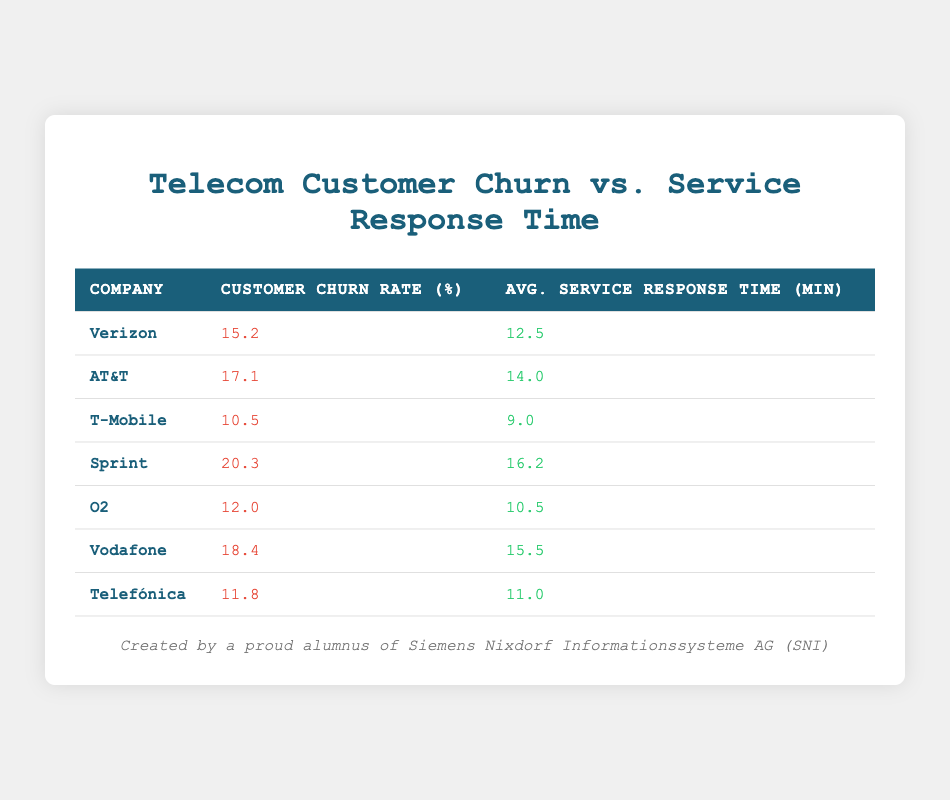What is the customer churn rate for Sprint? Sprint's customer churn rate is specifically listed in the table as 20.3%.
Answer: 20.3% Which company has the highest average service response time? The table shows that Sprint has the highest average service response time at 16.2 minutes.
Answer: Sprint What is the average customer churn rate for all the companies listed? To calculate the average, sum the customer churn rates: (15.2 + 17.1 + 10.5 + 20.3 + 12.0 + 18.4 + 11.8) = 105.3. There are 7 companies, so the average is 105.3 / 7 ≈ 15.04.
Answer: 15.04 Is the average service response time for T-Mobile less than 10 minutes? According to the table, T-Mobile's average service response time is 9.0 minutes, which is less than 10 minutes, making the statement true.
Answer: Yes Which company has the lowest customer churn rate, and how does it compare to the highest churn rate? The table indicates T-Mobile has the lowest churn rate at 10.5%. Sprint has the highest churn rate at 20.3%. The difference between them is 20.3 - 10.5 = 9.8 percentage points.
Answer: T-Mobile, 9.8 percentage points difference What is the total customer churn rate for the three companies with the lowest churn rates? The three companies with the lowest churn rates are T-Mobile (10.5%), Telefónica (11.8%), and O2 (12.0%). The total churn rate is (10.5 + 11.8 + 12.0) = 34.3%.
Answer: 34.3% Does Vodafone have a service response time greater than 15 minutes? Checking the table shows that Vodafone's response time is 15.5 minutes, which is indeed greater than 15 minutes, making the statement true.
Answer: Yes What is the median customer churn rate across the listed companies? To find the median, we first arrange the churn rates in ascending order: 10.5, 11.8, 12.0, 15.2, 17.1, 18.4, 20.3. With 7 values, the median is the 4th value, which is 15.2%.
Answer: 15.2% How does the average service response time for Verizon compare with that of O2? Verizon's average service response time is 12.5 minutes, while O2's is 10.5 minutes. Therefore, Verizon’s response time is longer by 12.5 - 10.5 = 2.0 minutes.
Answer: Longer by 2.0 minutes 